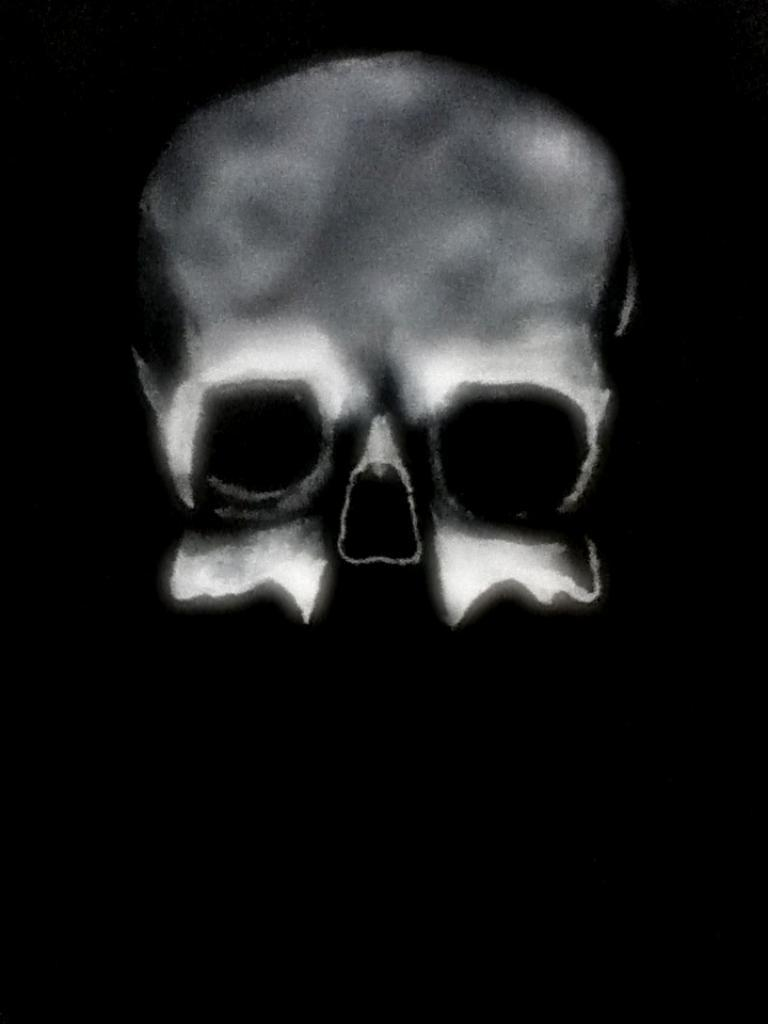What is the main subject of the image? There is a skull in the image. How does the son jump over the duck in the image? There is no son, jump, or duck present in the image; it only features a skull. 